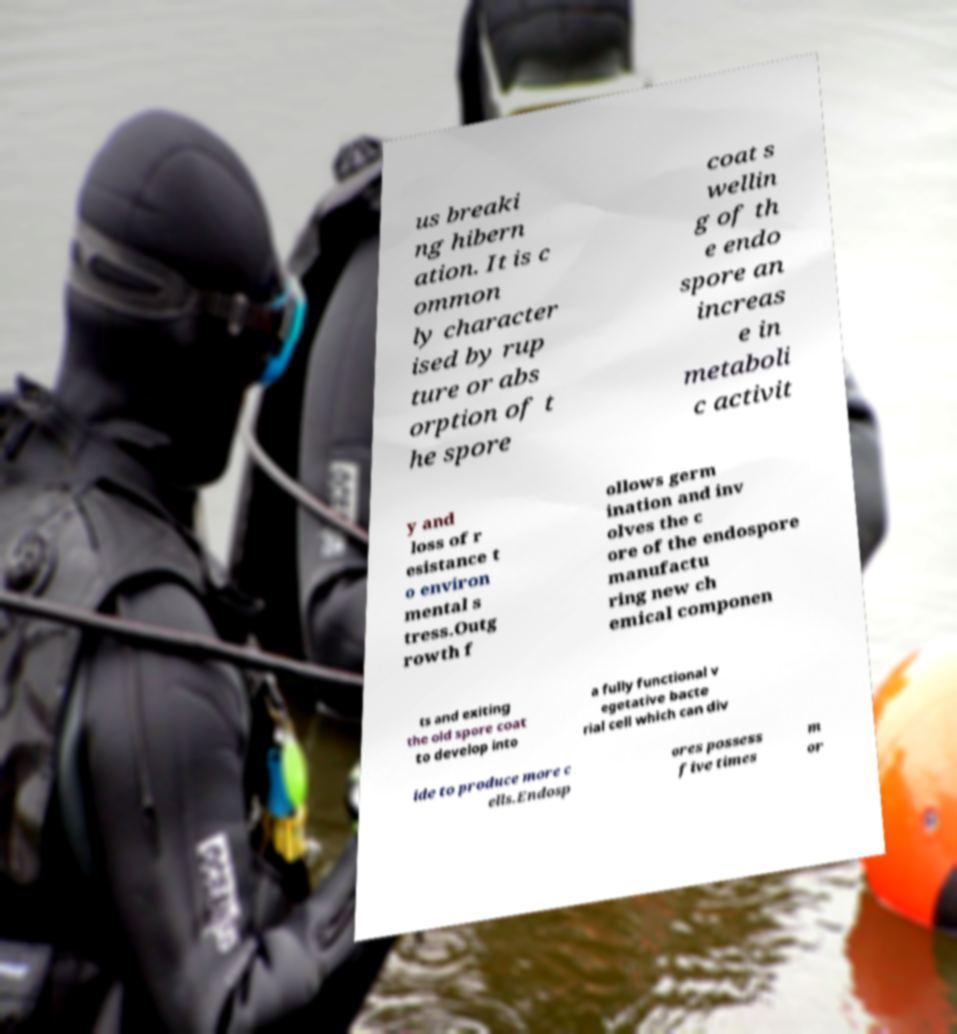I need the written content from this picture converted into text. Can you do that? us breaki ng hibern ation. It is c ommon ly character ised by rup ture or abs orption of t he spore coat s wellin g of th e endo spore an increas e in metaboli c activit y and loss of r esistance t o environ mental s tress.Outg rowth f ollows germ ination and inv olves the c ore of the endospore manufactu ring new ch emical componen ts and exiting the old spore coat to develop into a fully functional v egetative bacte rial cell which can div ide to produce more c ells.Endosp ores possess five times m or 